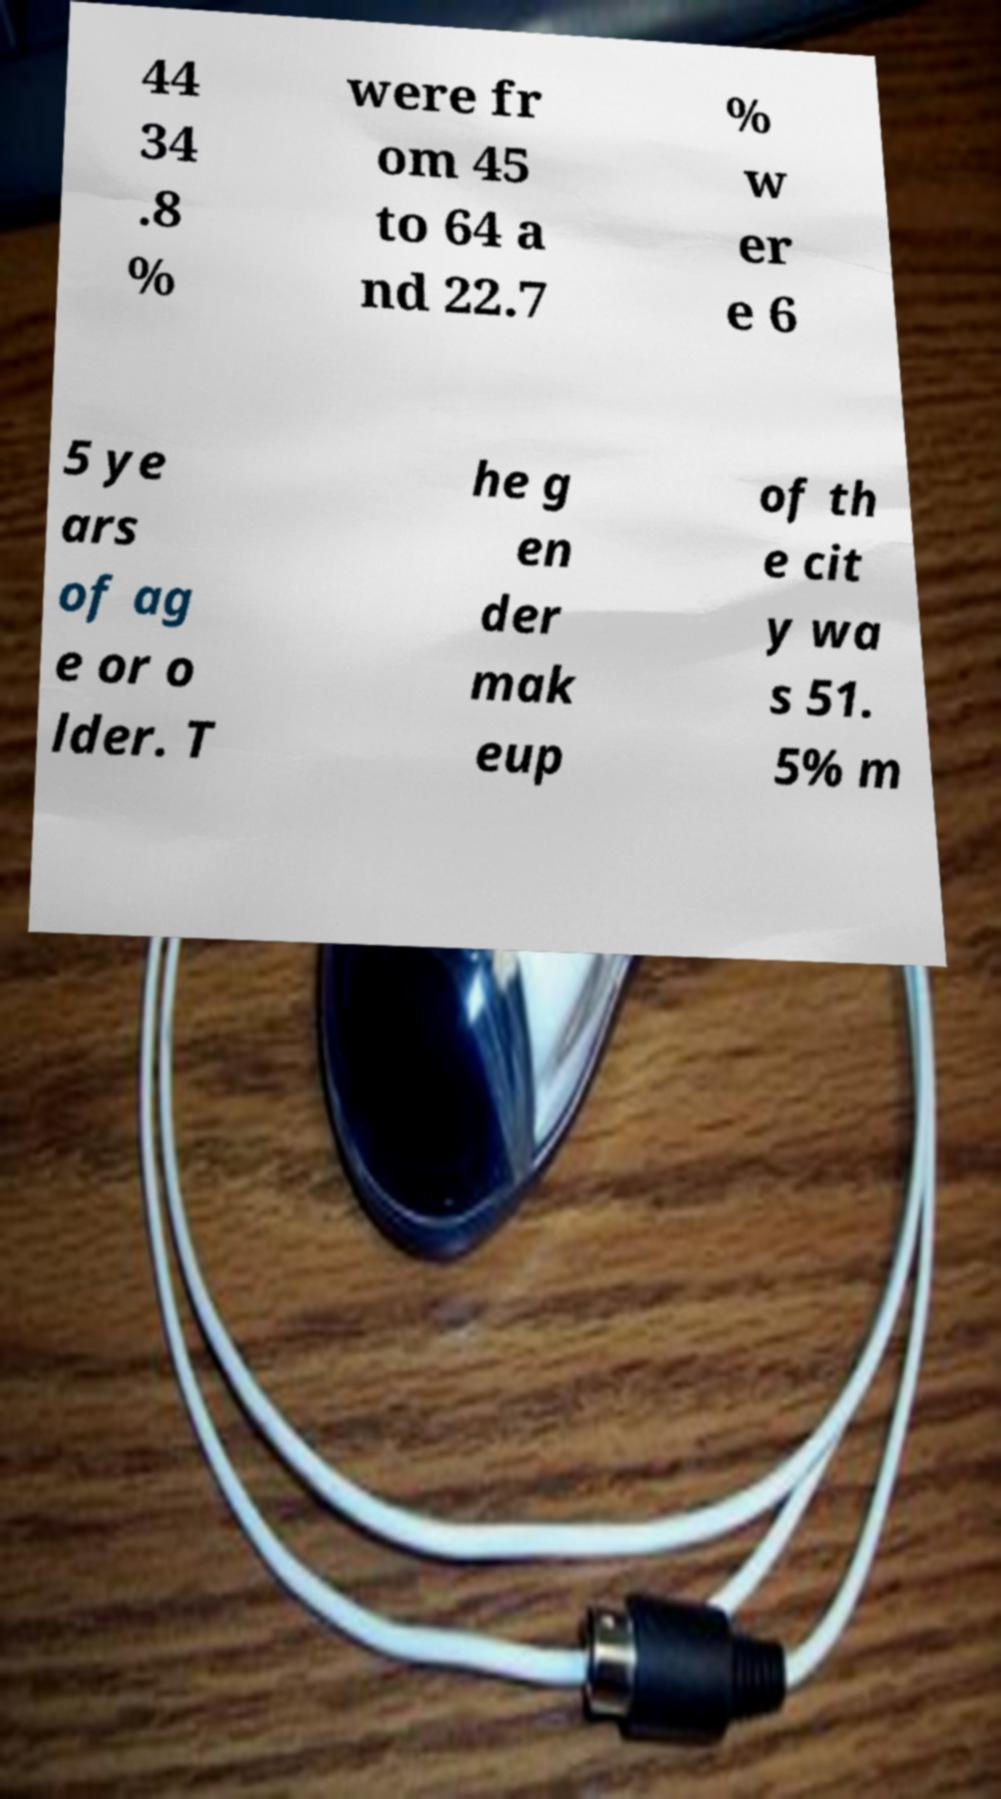There's text embedded in this image that I need extracted. Can you transcribe it verbatim? 44 34 .8 % were fr om 45 to 64 a nd 22.7 % w er e 6 5 ye ars of ag e or o lder. T he g en der mak eup of th e cit y wa s 51. 5% m 